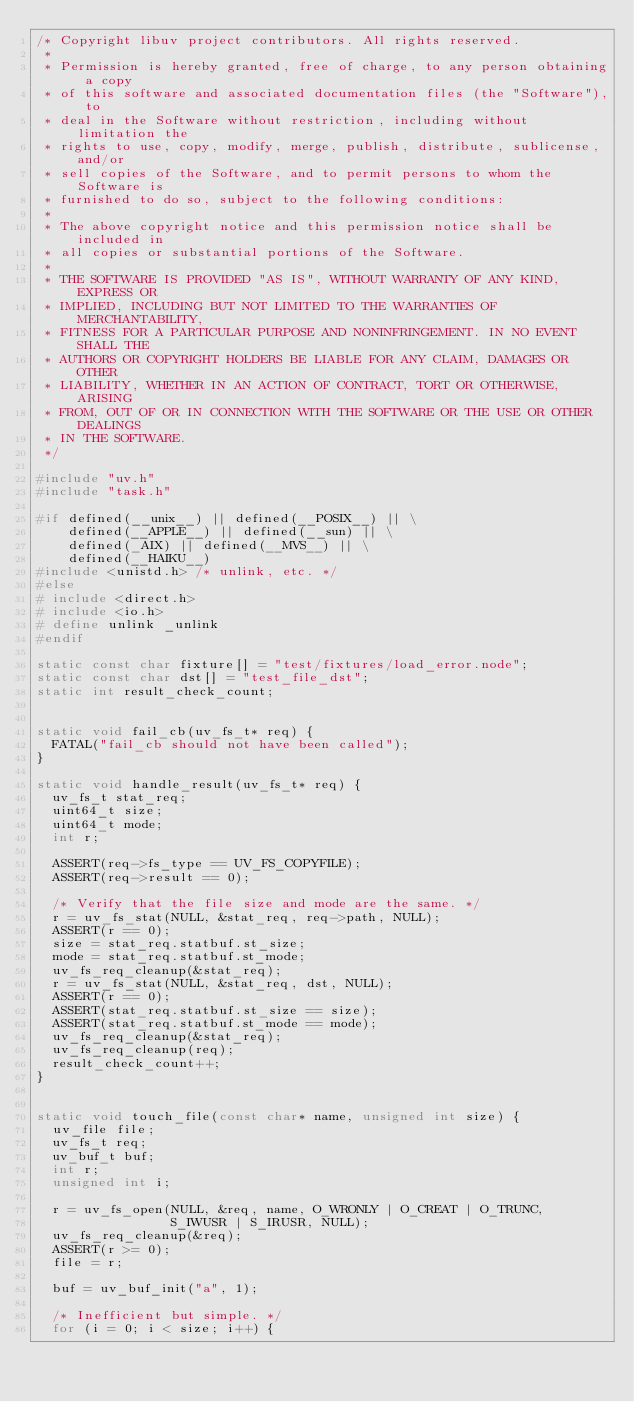Convert code to text. <code><loc_0><loc_0><loc_500><loc_500><_C_>/* Copyright libuv project contributors. All rights reserved.
 *
 * Permission is hereby granted, free of charge, to any person obtaining a copy
 * of this software and associated documentation files (the "Software"), to
 * deal in the Software without restriction, including without limitation the
 * rights to use, copy, modify, merge, publish, distribute, sublicense, and/or
 * sell copies of the Software, and to permit persons to whom the Software is
 * furnished to do so, subject to the following conditions:
 *
 * The above copyright notice and this permission notice shall be included in
 * all copies or substantial portions of the Software.
 *
 * THE SOFTWARE IS PROVIDED "AS IS", WITHOUT WARRANTY OF ANY KIND, EXPRESS OR
 * IMPLIED, INCLUDING BUT NOT LIMITED TO THE WARRANTIES OF MERCHANTABILITY,
 * FITNESS FOR A PARTICULAR PURPOSE AND NONINFRINGEMENT. IN NO EVENT SHALL THE
 * AUTHORS OR COPYRIGHT HOLDERS BE LIABLE FOR ANY CLAIM, DAMAGES OR OTHER
 * LIABILITY, WHETHER IN AN ACTION OF CONTRACT, TORT OR OTHERWISE, ARISING
 * FROM, OUT OF OR IN CONNECTION WITH THE SOFTWARE OR THE USE OR OTHER DEALINGS
 * IN THE SOFTWARE.
 */

#include "uv.h"
#include "task.h"

#if defined(__unix__) || defined(__POSIX__) || \
    defined(__APPLE__) || defined(__sun) || \
    defined(_AIX) || defined(__MVS__) || \
    defined(__HAIKU__)
#include <unistd.h> /* unlink, etc. */
#else
# include <direct.h>
# include <io.h>
# define unlink _unlink
#endif

static const char fixture[] = "test/fixtures/load_error.node";
static const char dst[] = "test_file_dst";
static int result_check_count;


static void fail_cb(uv_fs_t* req) {
  FATAL("fail_cb should not have been called");
}

static void handle_result(uv_fs_t* req) {
  uv_fs_t stat_req;
  uint64_t size;
  uint64_t mode;
  int r;

  ASSERT(req->fs_type == UV_FS_COPYFILE);
  ASSERT(req->result == 0);

  /* Verify that the file size and mode are the same. */
  r = uv_fs_stat(NULL, &stat_req, req->path, NULL);
  ASSERT(r == 0);
  size = stat_req.statbuf.st_size;
  mode = stat_req.statbuf.st_mode;
  uv_fs_req_cleanup(&stat_req);
  r = uv_fs_stat(NULL, &stat_req, dst, NULL);
  ASSERT(r == 0);
  ASSERT(stat_req.statbuf.st_size == size);
  ASSERT(stat_req.statbuf.st_mode == mode);
  uv_fs_req_cleanup(&stat_req);
  uv_fs_req_cleanup(req);
  result_check_count++;
}


static void touch_file(const char* name, unsigned int size) {
  uv_file file;
  uv_fs_t req;
  uv_buf_t buf;
  int r;
  unsigned int i;

  r = uv_fs_open(NULL, &req, name, O_WRONLY | O_CREAT | O_TRUNC,
                 S_IWUSR | S_IRUSR, NULL);
  uv_fs_req_cleanup(&req);
  ASSERT(r >= 0);
  file = r;

  buf = uv_buf_init("a", 1);

  /* Inefficient but simple. */
  for (i = 0; i < size; i++) {</code> 